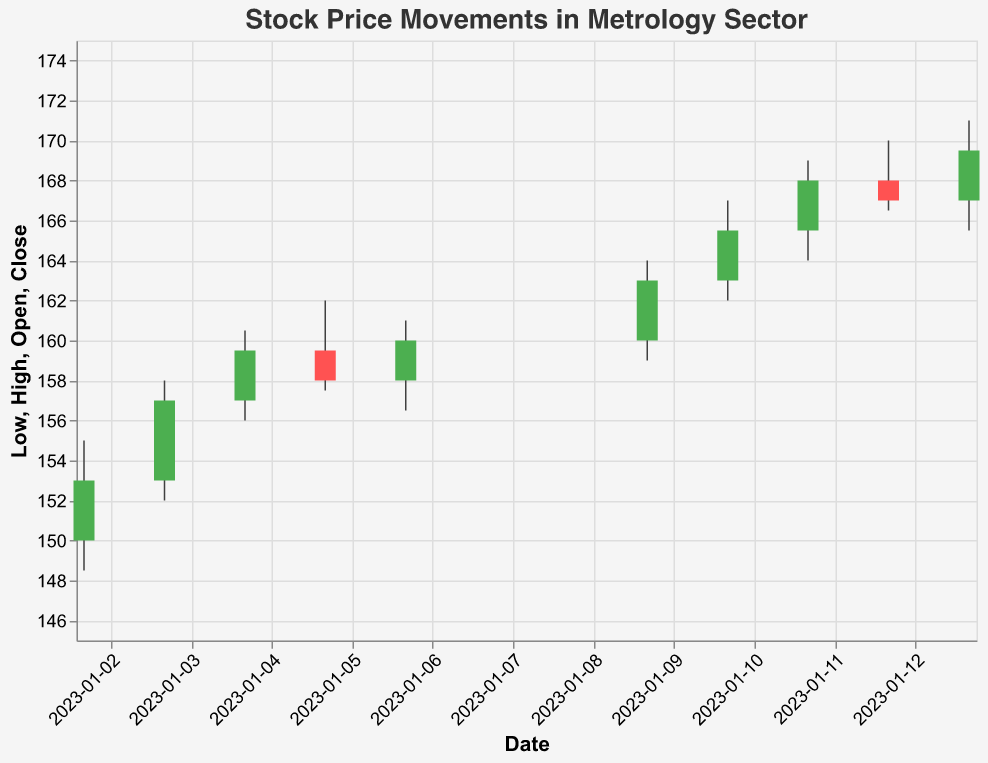What is the title of the plot? The title of the plot is usually positioned at the top and is specified in the figure's config. The title is "Stock Price Movements in Metrology Sector".
Answer: Stock Price Movements in Metrology Sector How many data points are plotted in the figure? By counting each entry for the date from "2023-01-02" to "2023-01-13", we observe that there are a total of 10 data points plotted.
Answer: 10 What color is used to indicate that the opening price is higher than the closing price? The visual rule for the bar's color encoding indicates that when the opening price is greater than the closing price, the bar color is red.
Answer: Red What was the highest stock price reached in this period? The highest stock price corresponds to the "High" value. By examining the data, the highest value is 171.00, reached on "2023-01-13".
Answer: 171.00 On which date did the stock price close at 157.00? To find the closing price of 157.00, we look at the "Close" field. The stock price closed at 157.00 on "2023-01-03".
Answer: 2023-01-03 What is the average closing price from January 2 to January 13, 2023? Sum all closing prices and divide by the number of data points (10): (153.00 + 157.00 + 159.50 + 158.00 + 160.00 + 163.00 + 165.50 + 168.00 + 167.00 + 169.50) / 10 = 1620 / 10 = 162.00
Answer: 162.00 Which day had the largest trading volume? The "Volume" field shows trading volumes. The highest trading volume is 1,500,000 on "2023-01-12".
Answer: 2023-01-12 How many days had a positive market sentiment? By examining the "MarketSentiment" field and counting instances of "Positive", we find that there are 7 days with a positive market sentiment.
Answer: 7 Was the stock price’s closing value higher on days with positive sentiment compared to neutral sentiment? Calculate the average closing price for positive days and neutral days. Positive days: (153 + 159.5 + 160 + 163 + 165.5 + 168 + 169.5)/7 = 162.79. Neutral days: (157 + 167)/2 = 162. The average closing value is higher on positive sentiment days.
Answer: Yes What was the market sentiment on the day the stock closed at its highest point? The highest closing price is on "2023-01-13" with 169.50. The "MarketSentiment" for that day is "Positive".
Answer: Positive 